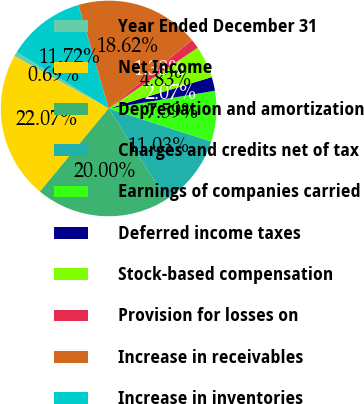Convert chart. <chart><loc_0><loc_0><loc_500><loc_500><pie_chart><fcel>Year Ended December 31<fcel>Net Income<fcel>Depreciation and amortization<fcel>Charges and credits net of tax<fcel>Earnings of companies carried<fcel>Deferred income taxes<fcel>Stock-based compensation<fcel>Provision for losses on<fcel>Increase in receivables<fcel>Increase in inventories<nl><fcel>0.69%<fcel>22.07%<fcel>20.0%<fcel>11.03%<fcel>7.59%<fcel>2.07%<fcel>4.83%<fcel>1.38%<fcel>18.62%<fcel>11.72%<nl></chart> 